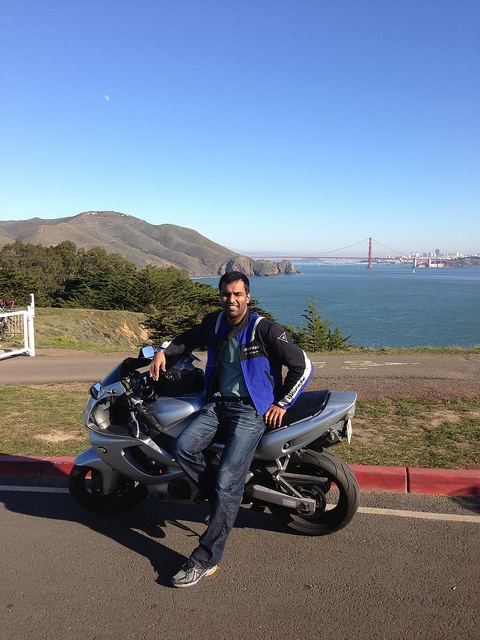Describe the objects in this image and their specific colors. I can see motorcycle in lightblue, black, gray, and darkgray tones and people in lightblue, black, gray, and navy tones in this image. 